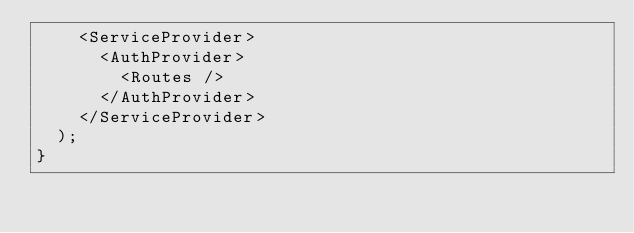Convert code to text. <code><loc_0><loc_0><loc_500><loc_500><_TypeScript_>    <ServiceProvider>
      <AuthProvider>
        <Routes />
      </AuthProvider>
    </ServiceProvider>
  );
}
</code> 